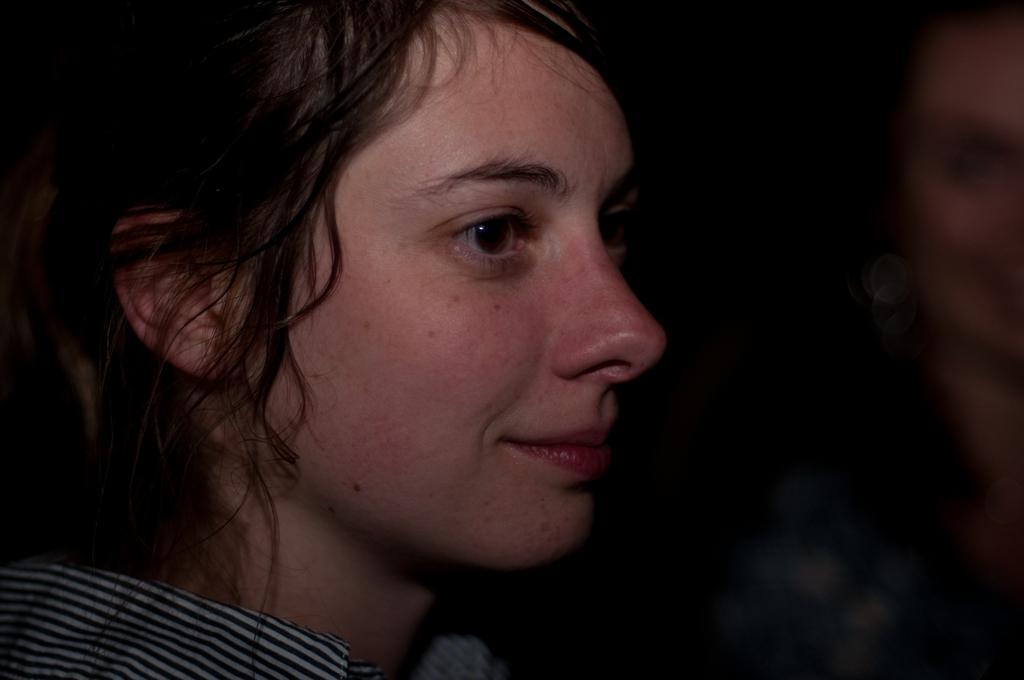Can you describe this image briefly? In the image we can see a woman smiling and she is wearing clothes. Beside her there is another person, the background is blurred. 